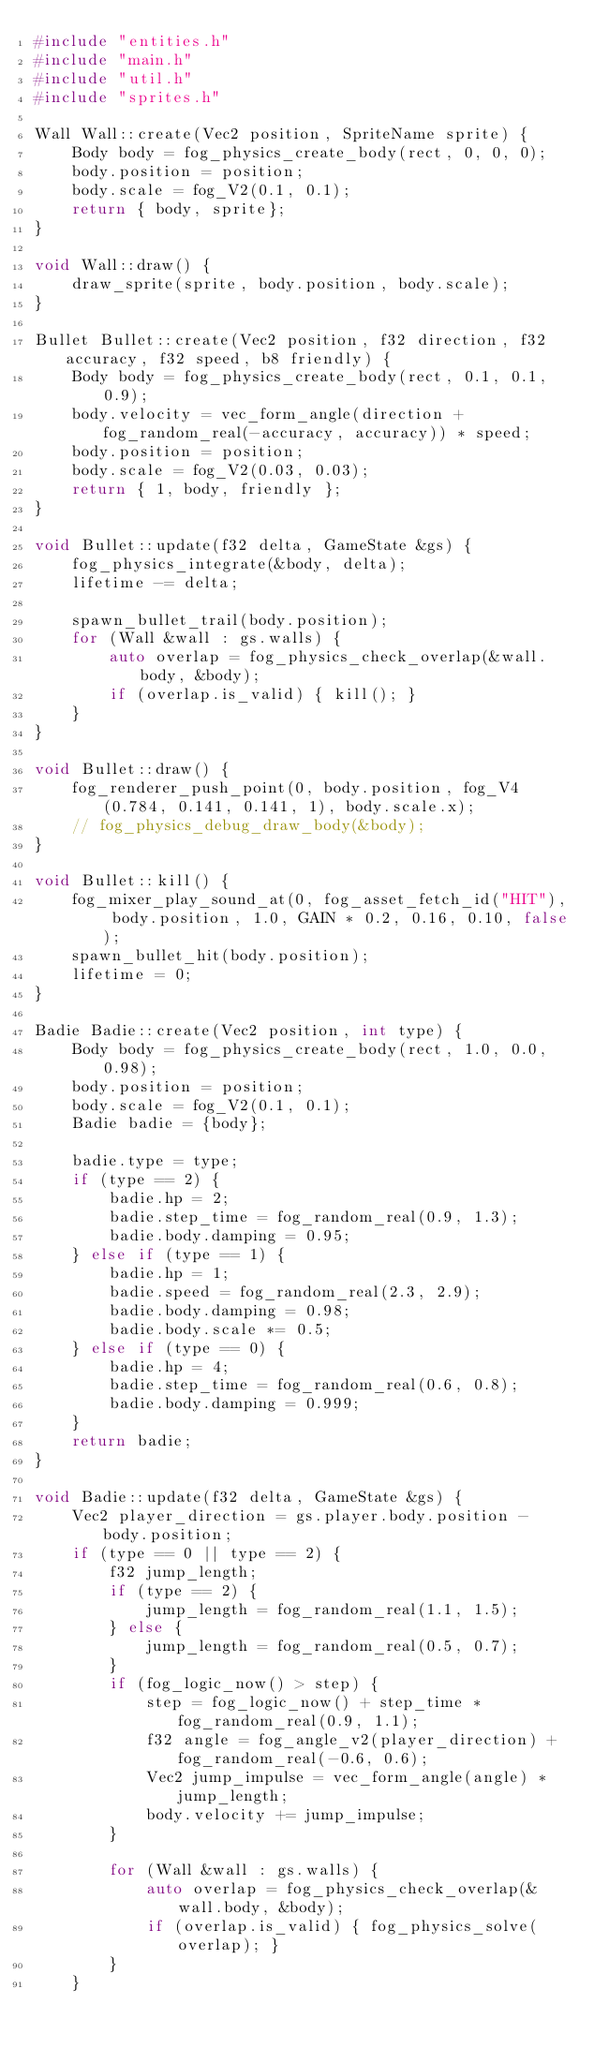<code> <loc_0><loc_0><loc_500><loc_500><_C++_>#include "entities.h"
#include "main.h"
#include "util.h"
#include "sprites.h"

Wall Wall::create(Vec2 position, SpriteName sprite) {
    Body body = fog_physics_create_body(rect, 0, 0, 0);
    body.position = position;
    body.scale = fog_V2(0.1, 0.1);
    return { body, sprite};
}

void Wall::draw() {
    draw_sprite(sprite, body.position, body.scale);
}

Bullet Bullet::create(Vec2 position, f32 direction, f32 accuracy, f32 speed, b8 friendly) {
    Body body = fog_physics_create_body(rect, 0.1, 0.1, 0.9);
    body.velocity = vec_form_angle(direction + fog_random_real(-accuracy, accuracy)) * speed;
    body.position = position;
    body.scale = fog_V2(0.03, 0.03);
    return { 1, body, friendly };
}

void Bullet::update(f32 delta, GameState &gs) {
    fog_physics_integrate(&body, delta);
    lifetime -= delta;

    spawn_bullet_trail(body.position);
    for (Wall &wall : gs.walls) {
        auto overlap = fog_physics_check_overlap(&wall.body, &body);
        if (overlap.is_valid) { kill(); }
    }
}

void Bullet::draw() {
    fog_renderer_push_point(0, body.position, fog_V4(0.784, 0.141, 0.141, 1), body.scale.x);
    // fog_physics_debug_draw_body(&body);
}

void Bullet::kill() {
    fog_mixer_play_sound_at(0, fog_asset_fetch_id("HIT"), body.position, 1.0, GAIN * 0.2, 0.16, 0.10, false);
    spawn_bullet_hit(body.position);
    lifetime = 0;
}

Badie Badie::create(Vec2 position, int type) {
    Body body = fog_physics_create_body(rect, 1.0, 0.0, 0.98);
    body.position = position;
    body.scale = fog_V2(0.1, 0.1);
    Badie badie = {body};

    badie.type = type;
    if (type == 2) {
        badie.hp = 2;
        badie.step_time = fog_random_real(0.9, 1.3);
        badie.body.damping = 0.95;
    } else if (type == 1) {
        badie.hp = 1;
        badie.speed = fog_random_real(2.3, 2.9);
        badie.body.damping = 0.98;
        badie.body.scale *= 0.5;
    } else if (type == 0) {
        badie.hp = 4;
        badie.step_time = fog_random_real(0.6, 0.8);
        badie.body.damping = 0.999;
    }
    return badie;
}

void Badie::update(f32 delta, GameState &gs) {
    Vec2 player_direction = gs.player.body.position - body.position;
    if (type == 0 || type == 2) {
        f32 jump_length;
        if (type == 2) {
            jump_length = fog_random_real(1.1, 1.5);
        } else {
            jump_length = fog_random_real(0.5, 0.7);
        }
        if (fog_logic_now() > step) {
            step = fog_logic_now() + step_time * fog_random_real(0.9, 1.1);
            f32 angle = fog_angle_v2(player_direction) + fog_random_real(-0.6, 0.6);
            Vec2 jump_impulse = vec_form_angle(angle) * jump_length;
            body.velocity += jump_impulse;
        }

        for (Wall &wall : gs.walls) {
            auto overlap = fog_physics_check_overlap(&wall.body, &body);
            if (overlap.is_valid) { fog_physics_solve(overlap); }
        }
    }
</code> 